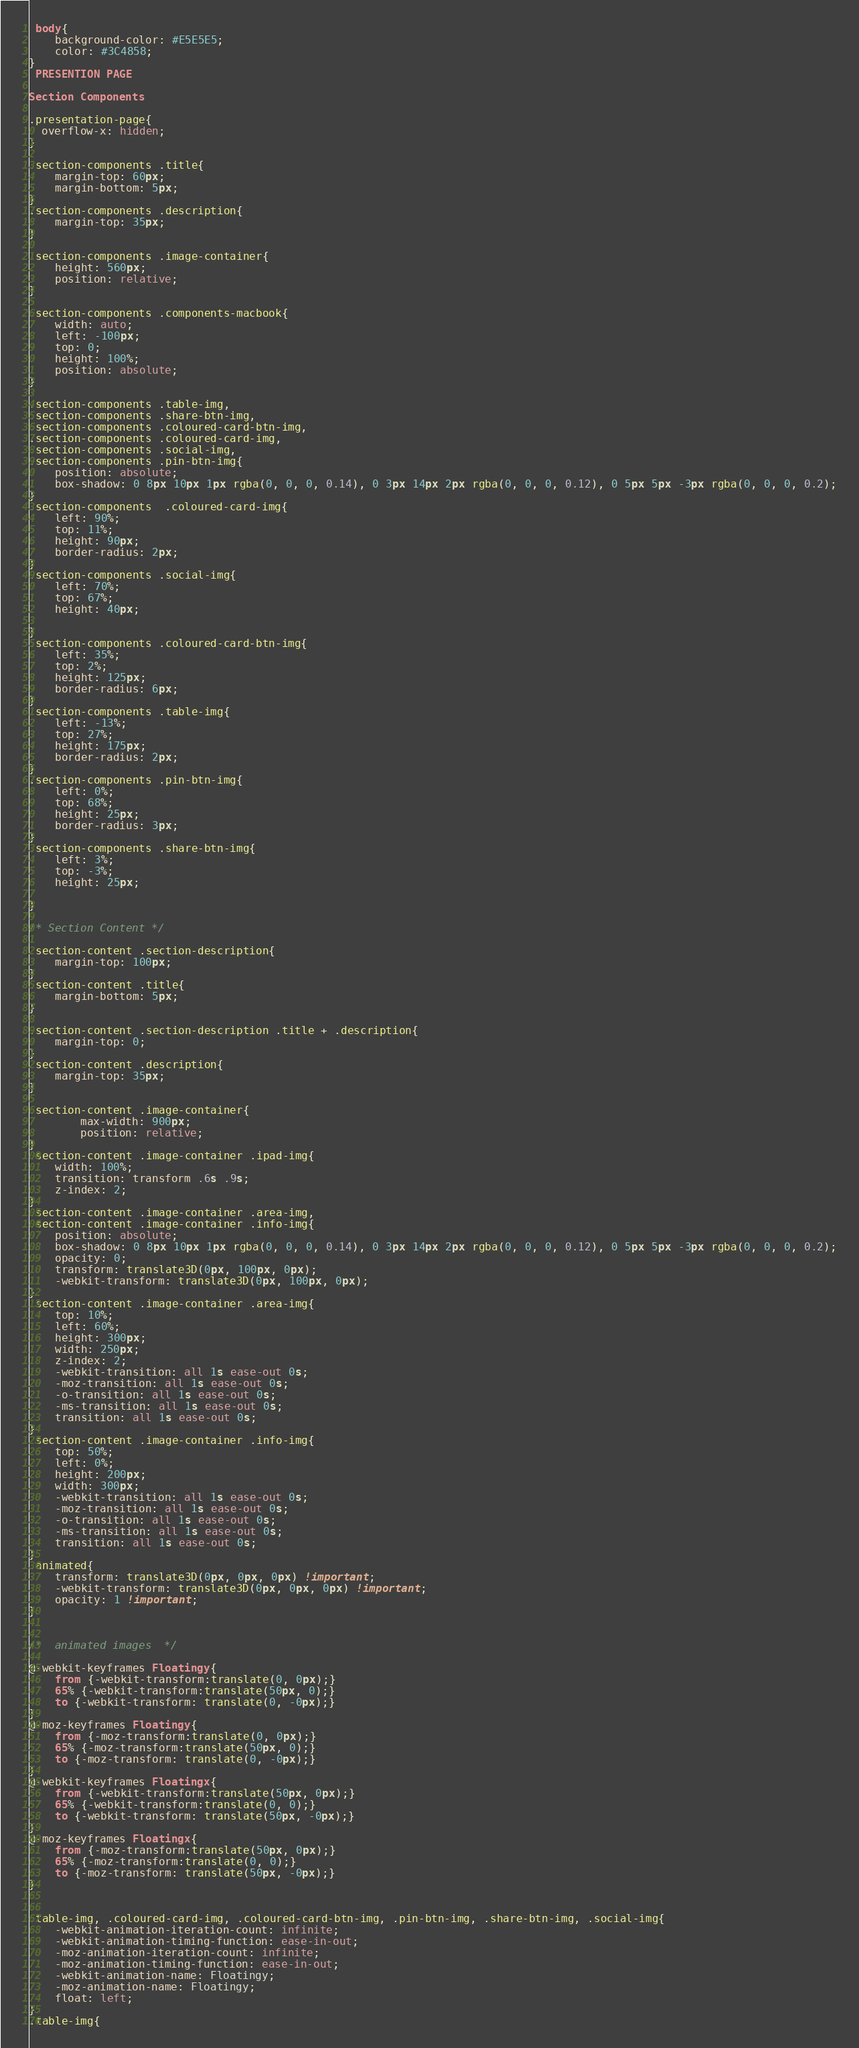Convert code to text. <code><loc_0><loc_0><loc_500><loc_500><_CSS_> body{
    background-color: #E5E5E5;
    color: #3C4858;
} 
 PRESENTION PAGE   

Section Components 

.presentation-page{
  overflow-x: hidden;
}

.section-components .title{
    margin-top: 60px;
    margin-bottom: 5px;
}
.section-components .description{
    margin-top: 35px;
}

.section-components .image-container{
    height: 560px;
    position: relative;
}

.section-components .components-macbook{
    width: auto;
    left: -100px;
    top: 0;
    height: 100%;
    position: absolute;
}

.section-components .table-img,
.section-components .share-btn-img,
.section-components .coloured-card-btn-img,
.section-components .coloured-card-img,
.section-components .social-img,
.section-components .pin-btn-img{
    position: absolute;
    box-shadow: 0 8px 10px 1px rgba(0, 0, 0, 0.14), 0 3px 14px 2px rgba(0, 0, 0, 0.12), 0 5px 5px -3px rgba(0, 0, 0, 0.2);
}
.section-components  .coloured-card-img{
    left: 90%;
    top: 11%;
    height: 90px;
    border-radius: 2px;
}
.section-components .social-img{
    left: 70%;
    top: 67%;
    height: 40px;

}
.section-components .coloured-card-btn-img{
    left: 35%;
    top: 2%;
    height: 125px;
    border-radius: 6px;
}
.section-components .table-img{
    left: -13%;
    top: 27%;
    height: 175px;
    border-radius: 2px;
}
.section-components .pin-btn-img{
    left: 0%;
    top: 68%;
    height: 25px;
    border-radius: 3px;
}
.section-components .share-btn-img{
    left: 3%;
    top: -3%;
    height: 25px;

}

/* Section Content */

.section-content .section-description{
    margin-top: 100px;
}
.section-content .title{
    margin-bottom: 5px;
}

.section-content .section-description .title + .description{
    margin-top: 0;
}
.section-content .description{
    margin-top: 35px;
}

.section-content .image-container{
        max-width: 900px;
        position: relative;
}
.section-content .image-container .ipad-img{
    width: 100%;
    transition: transform .6s .9s;
    z-index: 2;
}
.section-content .image-container .area-img,
.section-content .image-container .info-img{
    position: absolute;
    box-shadow: 0 8px 10px 1px rgba(0, 0, 0, 0.14), 0 3px 14px 2px rgba(0, 0, 0, 0.12), 0 5px 5px -3px rgba(0, 0, 0, 0.2);
    opacity: 0;
    transform: translate3D(0px, 100px, 0px);
    -webkit-transform: translate3D(0px, 100px, 0px);
}
.section-content .image-container .area-img{
    top: 10%;
    left: 60%;
    height: 300px;
    width: 250px;
    z-index: 2;
    -webkit-transition: all 1s ease-out 0s;
    -moz-transition: all 1s ease-out 0s;
    -o-transition: all 1s ease-out 0s;
    -ms-transition: all 1s ease-out 0s;
    transition: all 1s ease-out 0s;
}
.section-content .image-container .info-img{
    top: 50%;
    left: 0%;
    height: 200px;
    width: 300px;
    -webkit-transition: all 1s ease-out 0s;
    -moz-transition: all 1s ease-out 0s;
    -o-transition: all 1s ease-out 0s;
    -ms-transition: all 1s ease-out 0s;
    transition: all 1s ease-out 0s;
}
.animated{
    transform: translate3D(0px, 0px, 0px) !important;
    -webkit-transform: translate3D(0px, 0px, 0px) !important;
    opacity: 1 !important;
}


/*  animated images  */

@-webkit-keyframes Floatingy{
    from {-webkit-transform:translate(0, 0px);}
    65% {-webkit-transform:translate(50px, 0);}
    to {-webkit-transform: translate(0, -0px);}
}
@-moz-keyframes Floatingy{
    from {-moz-transform:translate(0, 0px);}
    65% {-moz-transform:translate(50px, 0);}
    to {-moz-transform: translate(0, -0px);}
}
@-webkit-keyframes Floatingx{
    from {-webkit-transform:translate(50px, 0px);}
    65% {-webkit-transform:translate(0, 0);}
    to {-webkit-transform: translate(50px, -0px);}
}
@-moz-keyframes Floatingx{
    from {-moz-transform:translate(50px, 0px);}
    65% {-moz-transform:translate(0, 0);}
    to {-moz-transform: translate(50px, -0px);}
}


.table-img, .coloured-card-img, .coloured-card-btn-img, .pin-btn-img, .share-btn-img, .social-img{
    -webkit-animation-iteration-count: infinite;
    -webkit-animation-timing-function: ease-in-out;
    -moz-animation-iteration-count: infinite;
    -moz-animation-timing-function: ease-in-out;
    -webkit-animation-name: Floatingy;
    -moz-animation-name: Floatingy;
    float: left;
}
.table-img{</code> 